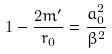Convert formula to latex. <formula><loc_0><loc_0><loc_500><loc_500>1 - \frac { 2 m ^ { \prime } } { r _ { 0 } } = \frac { a _ { 0 } ^ { 2 } } { \beta ^ { 2 } }</formula> 